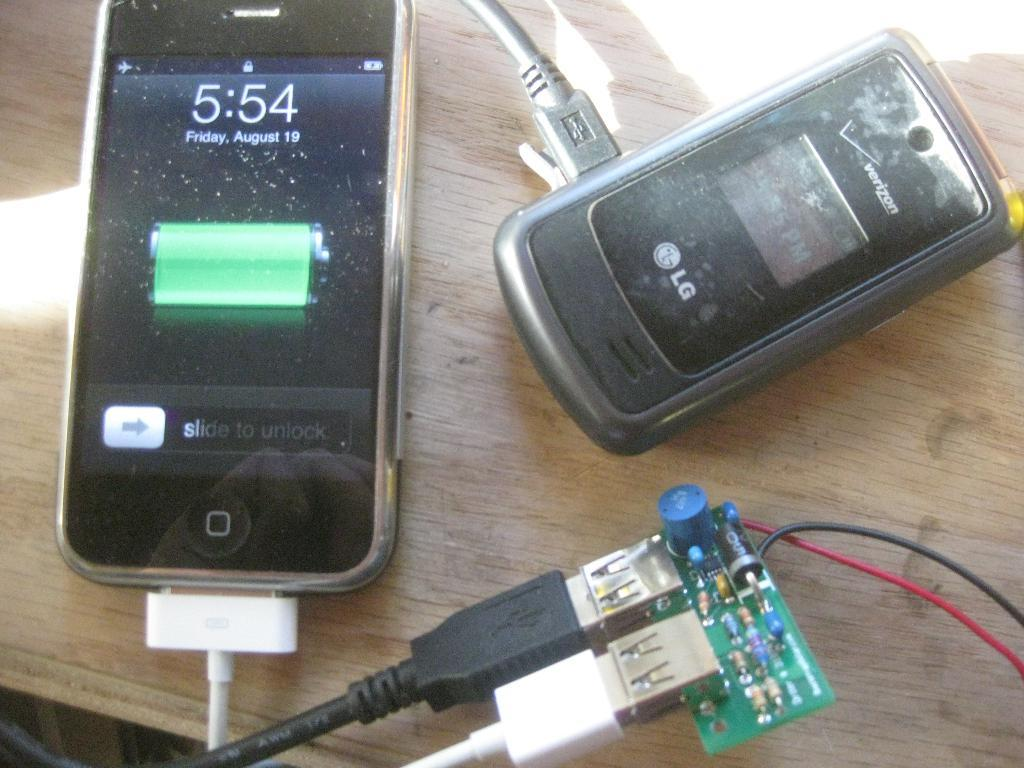<image>
Create a compact narrative representing the image presented. The date on the phone on the left hand side is Friday August 19. 